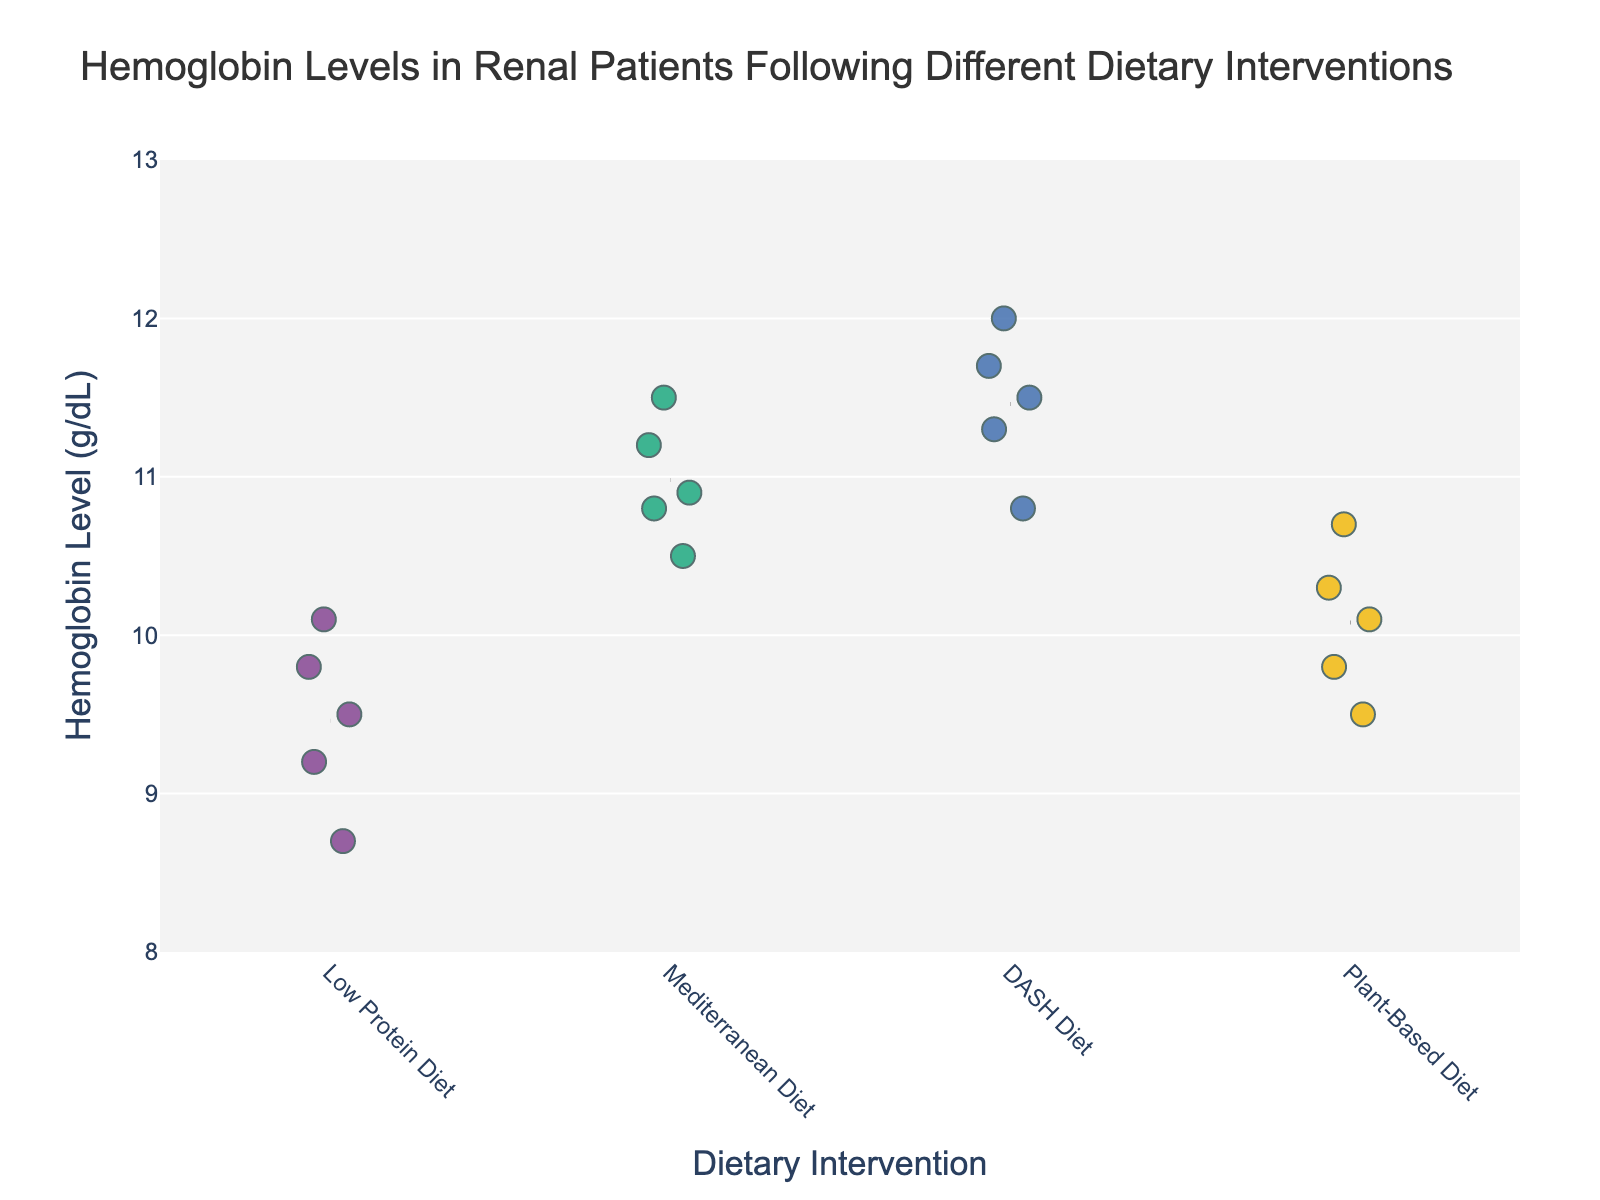What is the title of the figure? The title can be seen at the top of the plot, stating the main focus of the data visualization.
Answer: Hemoglobin Levels in Renal Patients Following Different Dietary Interventions How many dietary interventions are compared in the plot? By counting the unique categories along the x-axis, we identify the number of different dietary interventions included.
Answer: 4 Which dietary intervention shows the highest individual hemoglobin level? By examining the data points plotted on the y-axis, identify which category reaches the highest value.
Answer: DASH Diet What is the range of hemoglobin levels observed in patients following the Low Protein Diet? By observing the lowest and highest data points for the Low Protein Diet, we can determine the range.
Answer: 8.7 - 10.1 On average, which dietary intervention has the highest hemoglobin level? By looking at the mean lines drawn for each intervention, we can compare their average hemoglobin levels.
Answer: DASH Diet What is the average hemoglobin level for the Mediterranean Diet? Identify the mean line for the Mediterranean Diet and note its y-axis value.
Answer: 10.98 Which dietary intervention has the lowest variance in hemoglobin levels? By visually assessing the spread of data points for each intervention, determine which category has the most clustered points.
Answer: Plant-Based Diet Are any dietary interventions showing overlapping hemoglobin levels? Check if the y-axis values of data points from different interventions share any common range.
Answer: Yes What is the median hemoglobin level for the Plant-Based Diet? Arrange the hemoglobin levels for the Plant-Based Diet and find the middle value.
Answer: 10.0 Which dietary intervention appears to have the highest consistency in hemoglobin levels? By examining the clustering of data points around their respective means, identify the dietary intervention with the closest spread.
Answer: DASH Diet 